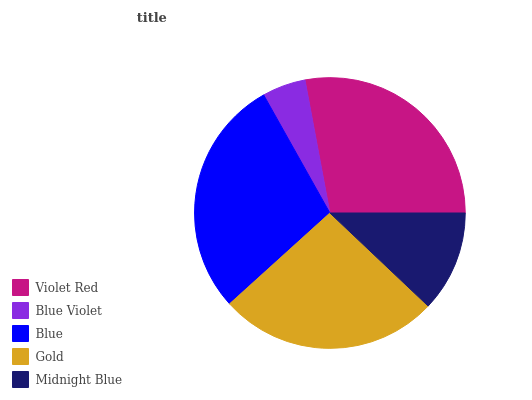Is Blue Violet the minimum?
Answer yes or no. Yes. Is Blue the maximum?
Answer yes or no. Yes. Is Blue the minimum?
Answer yes or no. No. Is Blue Violet the maximum?
Answer yes or no. No. Is Blue greater than Blue Violet?
Answer yes or no. Yes. Is Blue Violet less than Blue?
Answer yes or no. Yes. Is Blue Violet greater than Blue?
Answer yes or no. No. Is Blue less than Blue Violet?
Answer yes or no. No. Is Gold the high median?
Answer yes or no. Yes. Is Gold the low median?
Answer yes or no. Yes. Is Blue Violet the high median?
Answer yes or no. No. Is Blue Violet the low median?
Answer yes or no. No. 